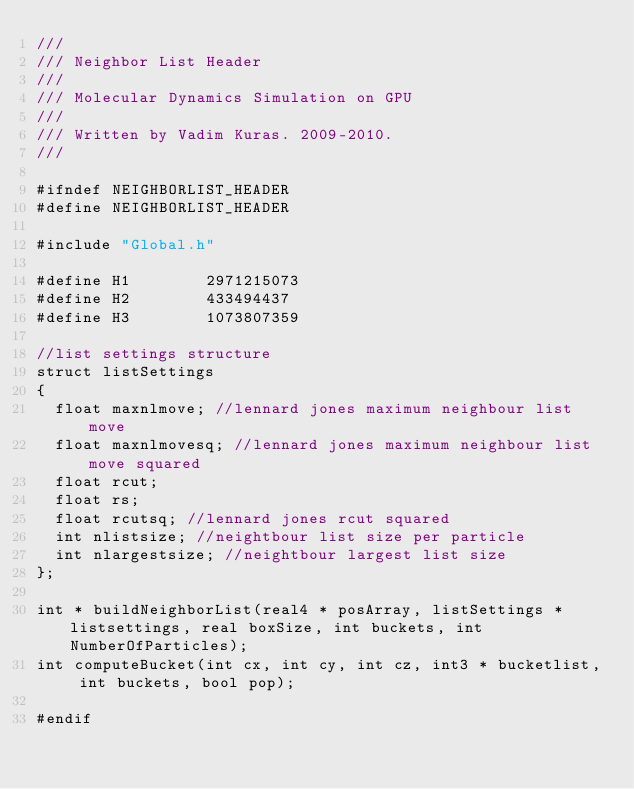Convert code to text. <code><loc_0><loc_0><loc_500><loc_500><_C_>///
/// Neighbor List Header
/// 
/// Molecular Dynamics Simulation on GPU
///
/// Written by Vadim Kuras. 2009-2010.
///

#ifndef NEIGHBORLIST_HEADER
#define NEIGHBORLIST_HEADER

#include "Global.h"

#define H1				2971215073
#define H2				433494437
#define H3				1073807359

//list settings structure
struct listSettings
{
	float maxnlmove; //lennard jones maximum neighbour list move
	float maxnlmovesq; //lennard jones maximum neighbour list move squared
	float rcut;
	float rs;
	float rcutsq; //lennard jones rcut squared
	int nlistsize; //neightbour list size per particle
	int nlargestsize; //neightbour largest list size
};

int * buildNeighborList(real4 * posArray, listSettings * listsettings, real boxSize, int buckets, int NumberOfParticles);
int computeBucket(int cx, int cy, int cz, int3 * bucketlist, int buckets, bool pop);

#endif</code> 